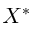Convert formula to latex. <formula><loc_0><loc_0><loc_500><loc_500>X ^ { * }</formula> 